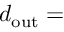Convert formula to latex. <formula><loc_0><loc_0><loc_500><loc_500>d _ { o u t } =</formula> 